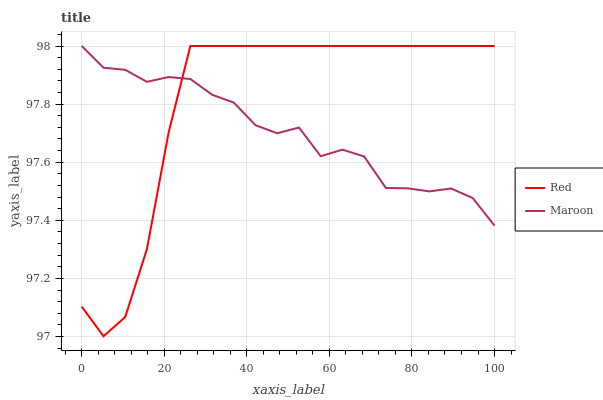Does Maroon have the minimum area under the curve?
Answer yes or no. Yes. Does Red have the maximum area under the curve?
Answer yes or no. Yes. Does Red have the minimum area under the curve?
Answer yes or no. No. Is Red the smoothest?
Answer yes or no. Yes. Is Maroon the roughest?
Answer yes or no. Yes. Is Red the roughest?
Answer yes or no. No. Does Red have the lowest value?
Answer yes or no. Yes. Does Red have the highest value?
Answer yes or no. Yes. Does Maroon intersect Red?
Answer yes or no. Yes. Is Maroon less than Red?
Answer yes or no. No. Is Maroon greater than Red?
Answer yes or no. No. 